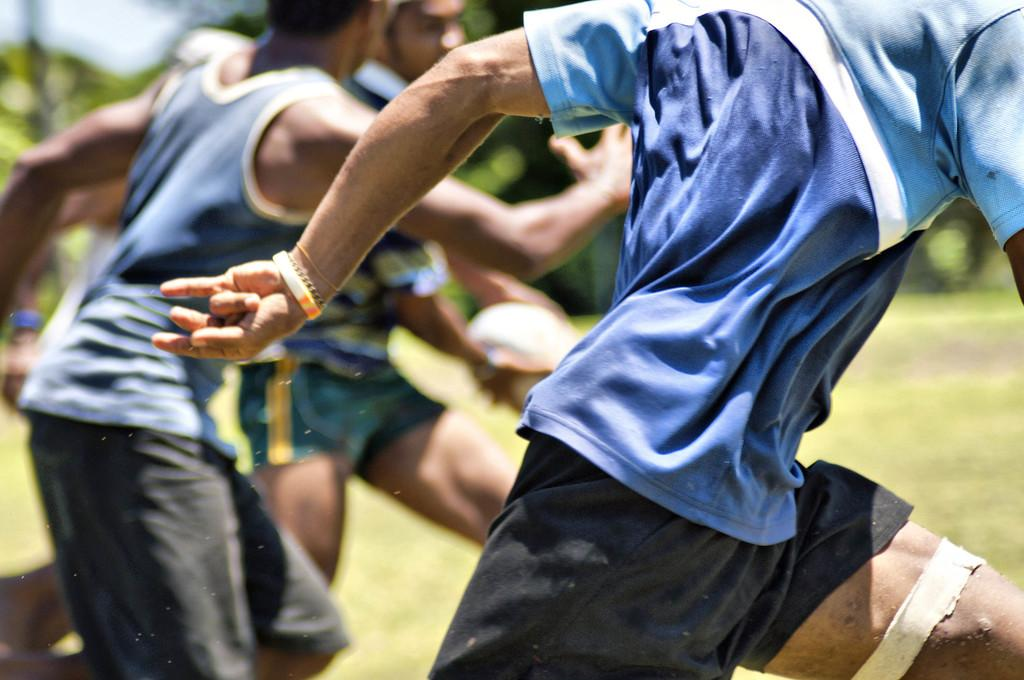What are the people in the image doing? The people in the image are running. What type of surface can be seen at the bottom of the image? There is grass on the surface at the bottom of the image. What can be seen in the background of the image? There are trees in the background of the image. What type of wax can be seen on the people's lips in the image? There is no wax or mention of lips in the image; the people are running on grass with trees in the background. 